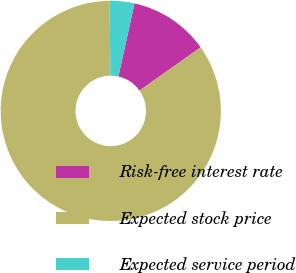Convert chart. <chart><loc_0><loc_0><loc_500><loc_500><pie_chart><fcel>Risk-free interest rate<fcel>Expected stock price<fcel>Expected service period<nl><fcel>11.74%<fcel>84.63%<fcel>3.64%<nl></chart> 